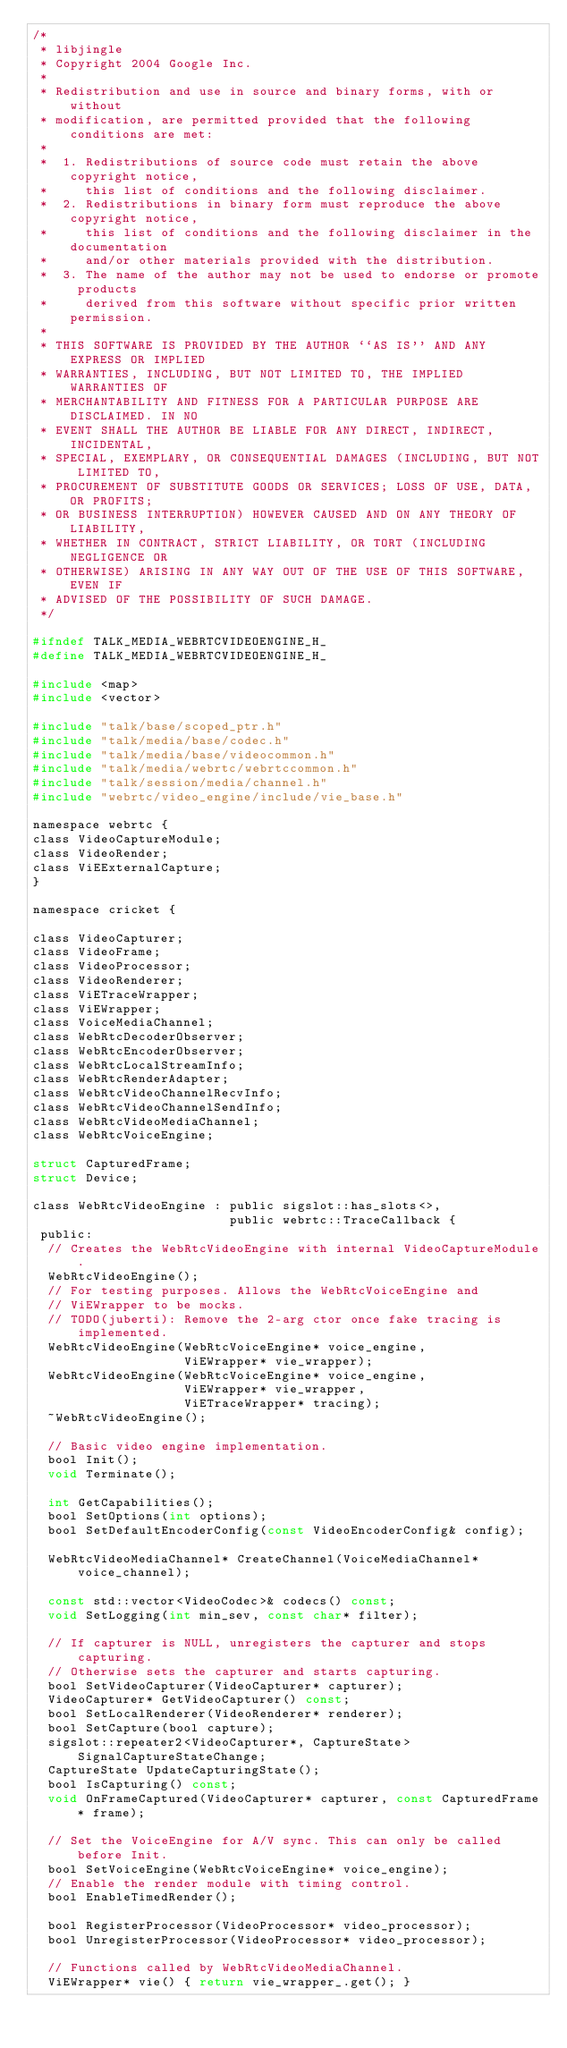<code> <loc_0><loc_0><loc_500><loc_500><_C_>/*
 * libjingle
 * Copyright 2004 Google Inc.
 *
 * Redistribution and use in source and binary forms, with or without
 * modification, are permitted provided that the following conditions are met:
 *
 *  1. Redistributions of source code must retain the above copyright notice,
 *     this list of conditions and the following disclaimer.
 *  2. Redistributions in binary form must reproduce the above copyright notice,
 *     this list of conditions and the following disclaimer in the documentation
 *     and/or other materials provided with the distribution.
 *  3. The name of the author may not be used to endorse or promote products
 *     derived from this software without specific prior written permission.
 *
 * THIS SOFTWARE IS PROVIDED BY THE AUTHOR ``AS IS'' AND ANY EXPRESS OR IMPLIED
 * WARRANTIES, INCLUDING, BUT NOT LIMITED TO, THE IMPLIED WARRANTIES OF
 * MERCHANTABILITY AND FITNESS FOR A PARTICULAR PURPOSE ARE DISCLAIMED. IN NO
 * EVENT SHALL THE AUTHOR BE LIABLE FOR ANY DIRECT, INDIRECT, INCIDENTAL,
 * SPECIAL, EXEMPLARY, OR CONSEQUENTIAL DAMAGES (INCLUDING, BUT NOT LIMITED TO,
 * PROCUREMENT OF SUBSTITUTE GOODS OR SERVICES; LOSS OF USE, DATA, OR PROFITS;
 * OR BUSINESS INTERRUPTION) HOWEVER CAUSED AND ON ANY THEORY OF LIABILITY,
 * WHETHER IN CONTRACT, STRICT LIABILITY, OR TORT (INCLUDING NEGLIGENCE OR
 * OTHERWISE) ARISING IN ANY WAY OUT OF THE USE OF THIS SOFTWARE, EVEN IF
 * ADVISED OF THE POSSIBILITY OF SUCH DAMAGE.
 */

#ifndef TALK_MEDIA_WEBRTCVIDEOENGINE_H_
#define TALK_MEDIA_WEBRTCVIDEOENGINE_H_

#include <map>
#include <vector>

#include "talk/base/scoped_ptr.h"
#include "talk/media/base/codec.h"
#include "talk/media/base/videocommon.h"
#include "talk/media/webrtc/webrtccommon.h"
#include "talk/session/media/channel.h"
#include "webrtc/video_engine/include/vie_base.h"

namespace webrtc {
class VideoCaptureModule;
class VideoRender;
class ViEExternalCapture;
}

namespace cricket {

class VideoCapturer;
class VideoFrame;
class VideoProcessor;
class VideoRenderer;
class ViETraceWrapper;
class ViEWrapper;
class VoiceMediaChannel;
class WebRtcDecoderObserver;
class WebRtcEncoderObserver;
class WebRtcLocalStreamInfo;
class WebRtcRenderAdapter;
class WebRtcVideoChannelRecvInfo;
class WebRtcVideoChannelSendInfo;
class WebRtcVideoMediaChannel;
class WebRtcVoiceEngine;

struct CapturedFrame;
struct Device;

class WebRtcVideoEngine : public sigslot::has_slots<>,
                          public webrtc::TraceCallback {
 public:
  // Creates the WebRtcVideoEngine with internal VideoCaptureModule.
  WebRtcVideoEngine();
  // For testing purposes. Allows the WebRtcVoiceEngine and
  // ViEWrapper to be mocks.
  // TODO(juberti): Remove the 2-arg ctor once fake tracing is implemented.
  WebRtcVideoEngine(WebRtcVoiceEngine* voice_engine,
                    ViEWrapper* vie_wrapper);
  WebRtcVideoEngine(WebRtcVoiceEngine* voice_engine,
                    ViEWrapper* vie_wrapper,
                    ViETraceWrapper* tracing);
  ~WebRtcVideoEngine();

  // Basic video engine implementation.
  bool Init();
  void Terminate();

  int GetCapabilities();
  bool SetOptions(int options);
  bool SetDefaultEncoderConfig(const VideoEncoderConfig& config);

  WebRtcVideoMediaChannel* CreateChannel(VoiceMediaChannel* voice_channel);

  const std::vector<VideoCodec>& codecs() const;
  void SetLogging(int min_sev, const char* filter);

  // If capturer is NULL, unregisters the capturer and stops capturing.
  // Otherwise sets the capturer and starts capturing.
  bool SetVideoCapturer(VideoCapturer* capturer);
  VideoCapturer* GetVideoCapturer() const;
  bool SetLocalRenderer(VideoRenderer* renderer);
  bool SetCapture(bool capture);
  sigslot::repeater2<VideoCapturer*, CaptureState> SignalCaptureStateChange;
  CaptureState UpdateCapturingState();
  bool IsCapturing() const;
  void OnFrameCaptured(VideoCapturer* capturer, const CapturedFrame* frame);

  // Set the VoiceEngine for A/V sync. This can only be called before Init.
  bool SetVoiceEngine(WebRtcVoiceEngine* voice_engine);
  // Enable the render module with timing control.
  bool EnableTimedRender();

  bool RegisterProcessor(VideoProcessor* video_processor);
  bool UnregisterProcessor(VideoProcessor* video_processor);

  // Functions called by WebRtcVideoMediaChannel.
  ViEWrapper* vie() { return vie_wrapper_.get(); }</code> 